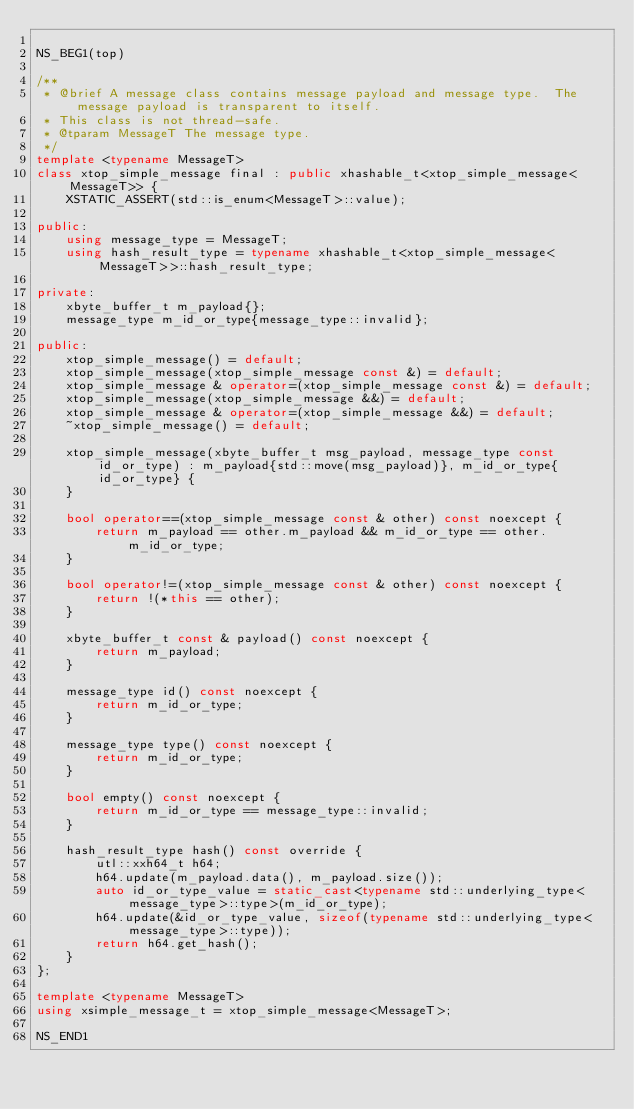Convert code to text. <code><loc_0><loc_0><loc_500><loc_500><_C++_>
NS_BEG1(top)

/**
 * @brief A message class contains message payload and message type.  The message payload is transparent to itself.
 * This class is not thread-safe.
 * @tparam MessageT The message type.
 */
template <typename MessageT>
class xtop_simple_message final : public xhashable_t<xtop_simple_message<MessageT>> {
    XSTATIC_ASSERT(std::is_enum<MessageT>::value);

public:
    using message_type = MessageT;
    using hash_result_type = typename xhashable_t<xtop_simple_message<MessageT>>::hash_result_type;

private:
    xbyte_buffer_t m_payload{};
    message_type m_id_or_type{message_type::invalid};

public:
    xtop_simple_message() = default;
    xtop_simple_message(xtop_simple_message const &) = default;
    xtop_simple_message & operator=(xtop_simple_message const &) = default;
    xtop_simple_message(xtop_simple_message &&) = default;
    xtop_simple_message & operator=(xtop_simple_message &&) = default;
    ~xtop_simple_message() = default;

    xtop_simple_message(xbyte_buffer_t msg_payload, message_type const id_or_type) : m_payload{std::move(msg_payload)}, m_id_or_type{id_or_type} {
    }

    bool operator==(xtop_simple_message const & other) const noexcept {
        return m_payload == other.m_payload && m_id_or_type == other.m_id_or_type;
    }

    bool operator!=(xtop_simple_message const & other) const noexcept {
        return !(*this == other);
    }

    xbyte_buffer_t const & payload() const noexcept {
        return m_payload;
    }

    message_type id() const noexcept {
        return m_id_or_type;
    }

    message_type type() const noexcept {
        return m_id_or_type;
    }

    bool empty() const noexcept {
        return m_id_or_type == message_type::invalid;
    }

    hash_result_type hash() const override {
        utl::xxh64_t h64;
        h64.update(m_payload.data(), m_payload.size());
        auto id_or_type_value = static_cast<typename std::underlying_type<message_type>::type>(m_id_or_type);
        h64.update(&id_or_type_value, sizeof(typename std::underlying_type<message_type>::type));
        return h64.get_hash();
    }
};

template <typename MessageT>
using xsimple_message_t = xtop_simple_message<MessageT>;

NS_END1
</code> 